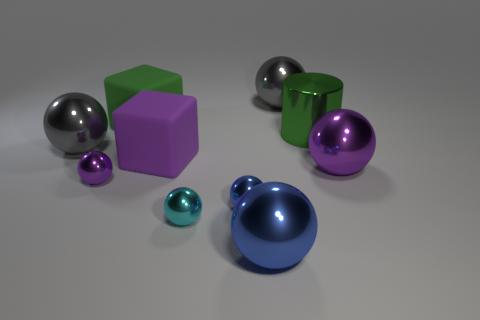Subtract all brown cylinders. How many blue spheres are left? 2 Subtract all tiny purple spheres. How many spheres are left? 6 Subtract all blue spheres. How many spheres are left? 5 Subtract all purple balls. Subtract all cyan cubes. How many balls are left? 5 Subtract all cubes. How many objects are left? 8 Add 2 green blocks. How many green blocks exist? 3 Subtract 1 cyan balls. How many objects are left? 9 Subtract all green metal things. Subtract all large matte balls. How many objects are left? 9 Add 1 large purple rubber cubes. How many large purple rubber cubes are left? 2 